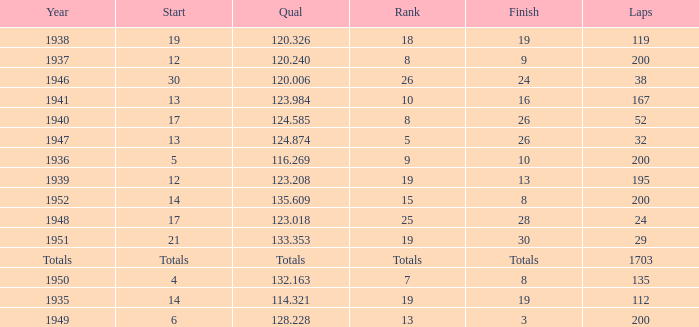In 1939, what was the finish? 13.0. 